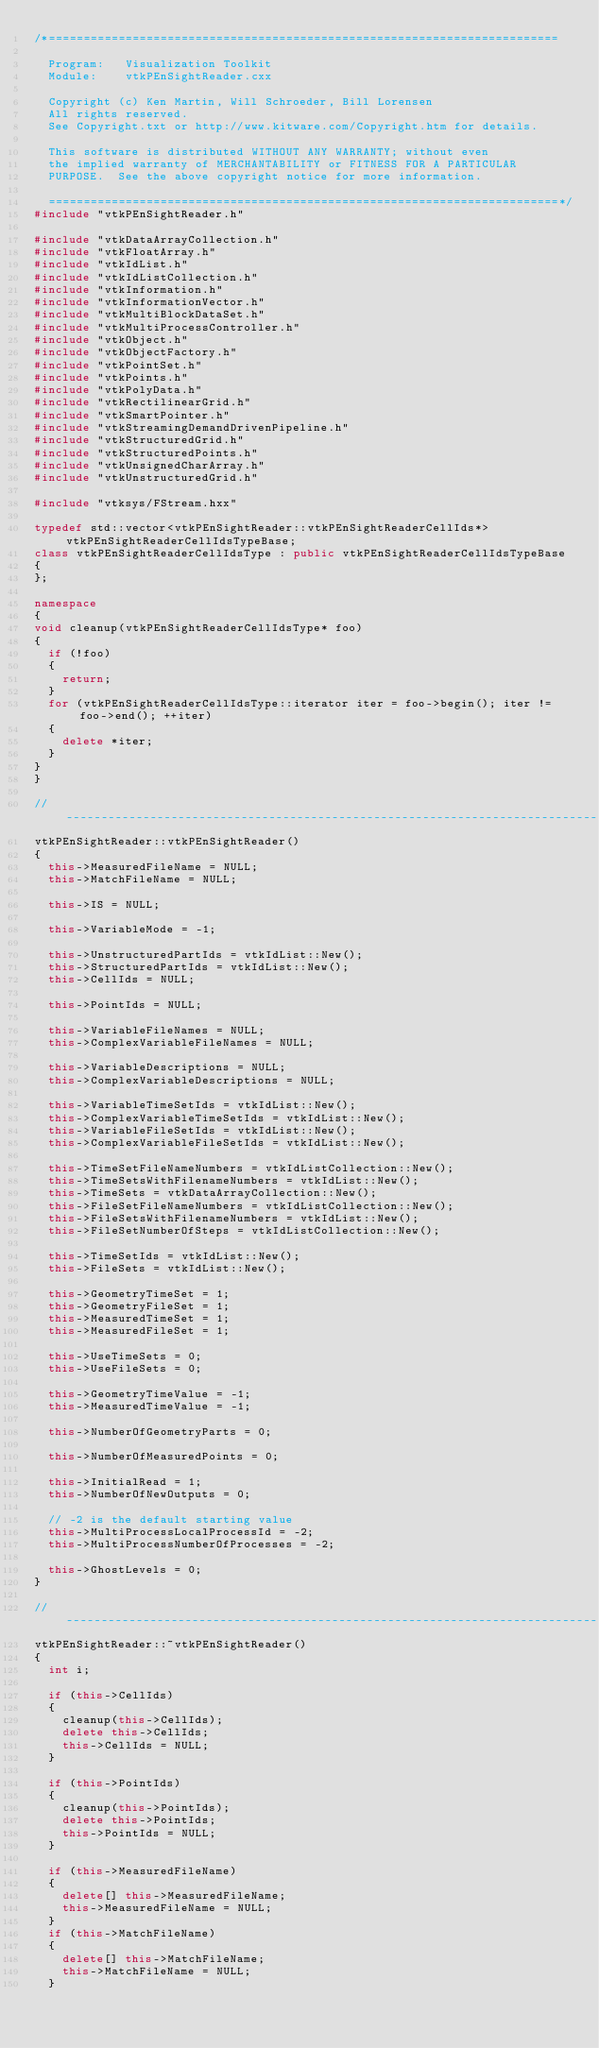<code> <loc_0><loc_0><loc_500><loc_500><_C++_>/*=========================================================================

  Program:   Visualization Toolkit
  Module:    vtkPEnSightReader.cxx

  Copyright (c) Ken Martin, Will Schroeder, Bill Lorensen
  All rights reserved.
  See Copyright.txt or http://www.kitware.com/Copyright.htm for details.

  This software is distributed WITHOUT ANY WARRANTY; without even
  the implied warranty of MERCHANTABILITY or FITNESS FOR A PARTICULAR
  PURPOSE.  See the above copyright notice for more information.

  =========================================================================*/
#include "vtkPEnSightReader.h"

#include "vtkDataArrayCollection.h"
#include "vtkFloatArray.h"
#include "vtkIdList.h"
#include "vtkIdListCollection.h"
#include "vtkInformation.h"
#include "vtkInformationVector.h"
#include "vtkMultiBlockDataSet.h"
#include "vtkMultiProcessController.h"
#include "vtkObject.h"
#include "vtkObjectFactory.h"
#include "vtkPointSet.h"
#include "vtkPoints.h"
#include "vtkPolyData.h"
#include "vtkRectilinearGrid.h"
#include "vtkSmartPointer.h"
#include "vtkStreamingDemandDrivenPipeline.h"
#include "vtkStructuredGrid.h"
#include "vtkStructuredPoints.h"
#include "vtkUnsignedCharArray.h"
#include "vtkUnstructuredGrid.h"

#include "vtksys/FStream.hxx"

typedef std::vector<vtkPEnSightReader::vtkPEnSightReaderCellIds*> vtkPEnSightReaderCellIdsTypeBase;
class vtkPEnSightReaderCellIdsType : public vtkPEnSightReaderCellIdsTypeBase
{
};

namespace
{
void cleanup(vtkPEnSightReaderCellIdsType* foo)
{
  if (!foo)
  {
    return;
  }
  for (vtkPEnSightReaderCellIdsType::iterator iter = foo->begin(); iter != foo->end(); ++iter)
  {
    delete *iter;
  }
}
}

//----------------------------------------------------------------------------
vtkPEnSightReader::vtkPEnSightReader()
{
  this->MeasuredFileName = NULL;
  this->MatchFileName = NULL;

  this->IS = NULL;

  this->VariableMode = -1;

  this->UnstructuredPartIds = vtkIdList::New();
  this->StructuredPartIds = vtkIdList::New();
  this->CellIds = NULL;

  this->PointIds = NULL;

  this->VariableFileNames = NULL;
  this->ComplexVariableFileNames = NULL;

  this->VariableDescriptions = NULL;
  this->ComplexVariableDescriptions = NULL;

  this->VariableTimeSetIds = vtkIdList::New();
  this->ComplexVariableTimeSetIds = vtkIdList::New();
  this->VariableFileSetIds = vtkIdList::New();
  this->ComplexVariableFileSetIds = vtkIdList::New();

  this->TimeSetFileNameNumbers = vtkIdListCollection::New();
  this->TimeSetsWithFilenameNumbers = vtkIdList::New();
  this->TimeSets = vtkDataArrayCollection::New();
  this->FileSetFileNameNumbers = vtkIdListCollection::New();
  this->FileSetsWithFilenameNumbers = vtkIdList::New();
  this->FileSetNumberOfSteps = vtkIdListCollection::New();

  this->TimeSetIds = vtkIdList::New();
  this->FileSets = vtkIdList::New();

  this->GeometryTimeSet = 1;
  this->GeometryFileSet = 1;
  this->MeasuredTimeSet = 1;
  this->MeasuredFileSet = 1;

  this->UseTimeSets = 0;
  this->UseFileSets = 0;

  this->GeometryTimeValue = -1;
  this->MeasuredTimeValue = -1;

  this->NumberOfGeometryParts = 0;

  this->NumberOfMeasuredPoints = 0;

  this->InitialRead = 1;
  this->NumberOfNewOutputs = 0;

  // -2 is the default starting value
  this->MultiProcessLocalProcessId = -2;
  this->MultiProcessNumberOfProcesses = -2;

  this->GhostLevels = 0;
}

//----------------------------------------------------------------------------
vtkPEnSightReader::~vtkPEnSightReader()
{
  int i;

  if (this->CellIds)
  {
    cleanup(this->CellIds);
    delete this->CellIds;
    this->CellIds = NULL;
  }

  if (this->PointIds)
  {
    cleanup(this->PointIds);
    delete this->PointIds;
    this->PointIds = NULL;
  }

  if (this->MeasuredFileName)
  {
    delete[] this->MeasuredFileName;
    this->MeasuredFileName = NULL;
  }
  if (this->MatchFileName)
  {
    delete[] this->MatchFileName;
    this->MatchFileName = NULL;
  }
</code> 